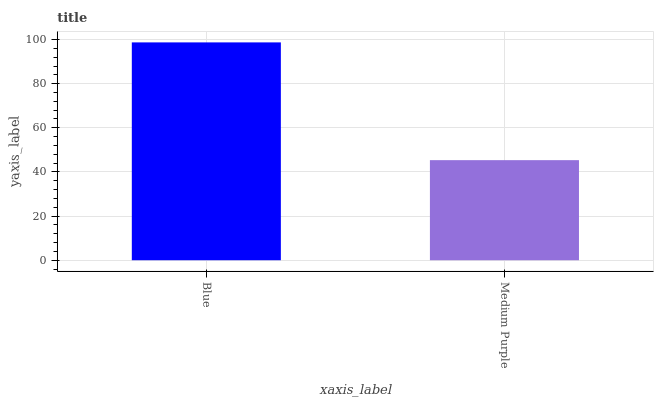Is Medium Purple the minimum?
Answer yes or no. Yes. Is Blue the maximum?
Answer yes or no. Yes. Is Medium Purple the maximum?
Answer yes or no. No. Is Blue greater than Medium Purple?
Answer yes or no. Yes. Is Medium Purple less than Blue?
Answer yes or no. Yes. Is Medium Purple greater than Blue?
Answer yes or no. No. Is Blue less than Medium Purple?
Answer yes or no. No. Is Blue the high median?
Answer yes or no. Yes. Is Medium Purple the low median?
Answer yes or no. Yes. Is Medium Purple the high median?
Answer yes or no. No. Is Blue the low median?
Answer yes or no. No. 